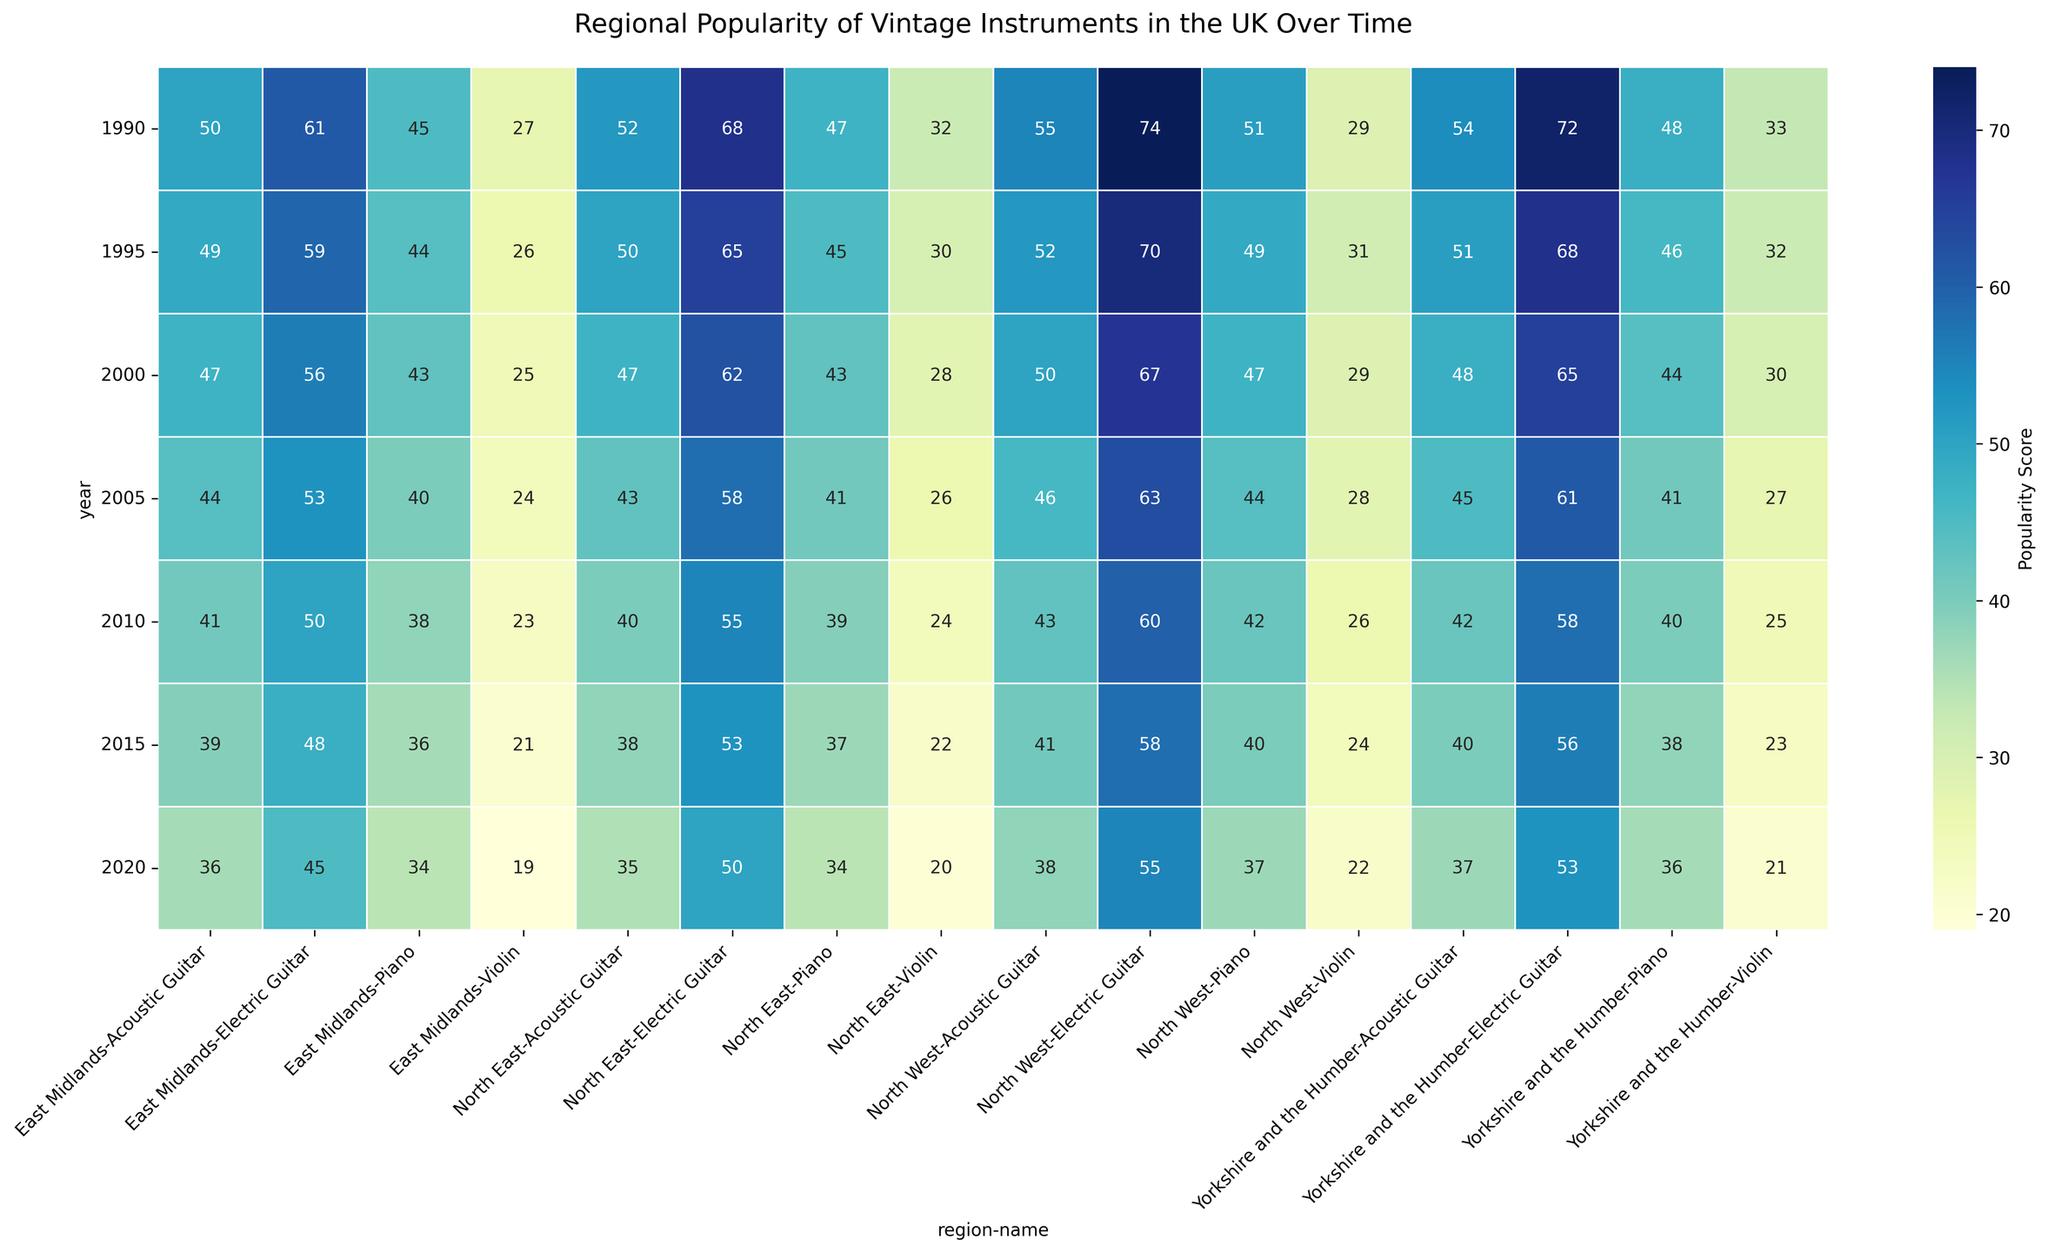What is the overall trend in the popularity of the electric guitar in the North East from 1990 to 2020? Examine the year-by-year values for the electric guitar in the North East region. The scores are 68 (1990), 65 (1995), 62 (2000), 58 (2005), 55 (2010), 53 (2015), and 50 (2020). Notice the gradual decline over years.
Answer: Gradual decline Which region had the highest popularity score for the piano in 1990? Compare the piano scores for all regions in 1990. North East (47), North West (51), Yorkshire and the Humber (48), East Midlands (45). The highest score is 51 in the North West.
Answer: North West Which instrument in Yorkshire and the Humber showed the least change in popularity from 1990 to 2020? Check the difference in scores for each instrument in Yorkshire and the Humber between 1990 and 2020. Electric Guitar (72 to 53), Acoustic Guitar (54 to 37), Piano (48 to 36), Violin (33 to 21). Violin shows a change of 12, less than other instruments.
Answer: Violin How does the popularity of the acoustic guitar in 2015 compare between the East Midlands and North West regions? Compare the acoustic guitar scores in 2015: East Midlands (39) and North West (41). The score in the North West is higher by 2 points.
Answer: North West is higher Which year showed the smallest gap between the popularity scores of the electric guitar and violin in the North West region? Calculate the differences for each year in the North West: 1990 (74-29=45), 1995 (70-31=39), 2000 (67-29=38), 2005 (63-28=35), 2010 (60-26=34), 2015 (58-24=34), 2020 (55-22=33). The smallest gap is 33 in 2020.
Answer: 2020 In which year was the popularity of the piano in the East Midlands highest? Identify the highest value for the piano in the East Midlands across all years: 1990 (45), 1995 (44), 2000 (43), 2005 (40), 2010 (38), 2015 (36), 2020 (34). The highest score is 45 in 1990.
Answer: 1990 What is the average popularity of the violin in the North East from 1990 to 2020? Add all violin scores for North East and divide by the number of years: (32 + 30 + 28 + 26 + 24 + 22 + 20) / 7 = 182 / 7 ≈ 26
Answer: 26 Which instrument had the most consistent popularity in the North West from 1990 to 2020? Find the standard deviation for each instrument’s scores in the North West. The electric guitar (74, 70, 67, 63, 60, 58, 55), acoustic guitar (55, 52, 50, 46, 43, 41, 38), piano (51, 49, 47, 44, 42, 40, 37), violin (29, 31, 29, 28, 26, 24, 22). The acoustic guitar has the lowest standard deviation.
Answer: Acoustic Guitar 